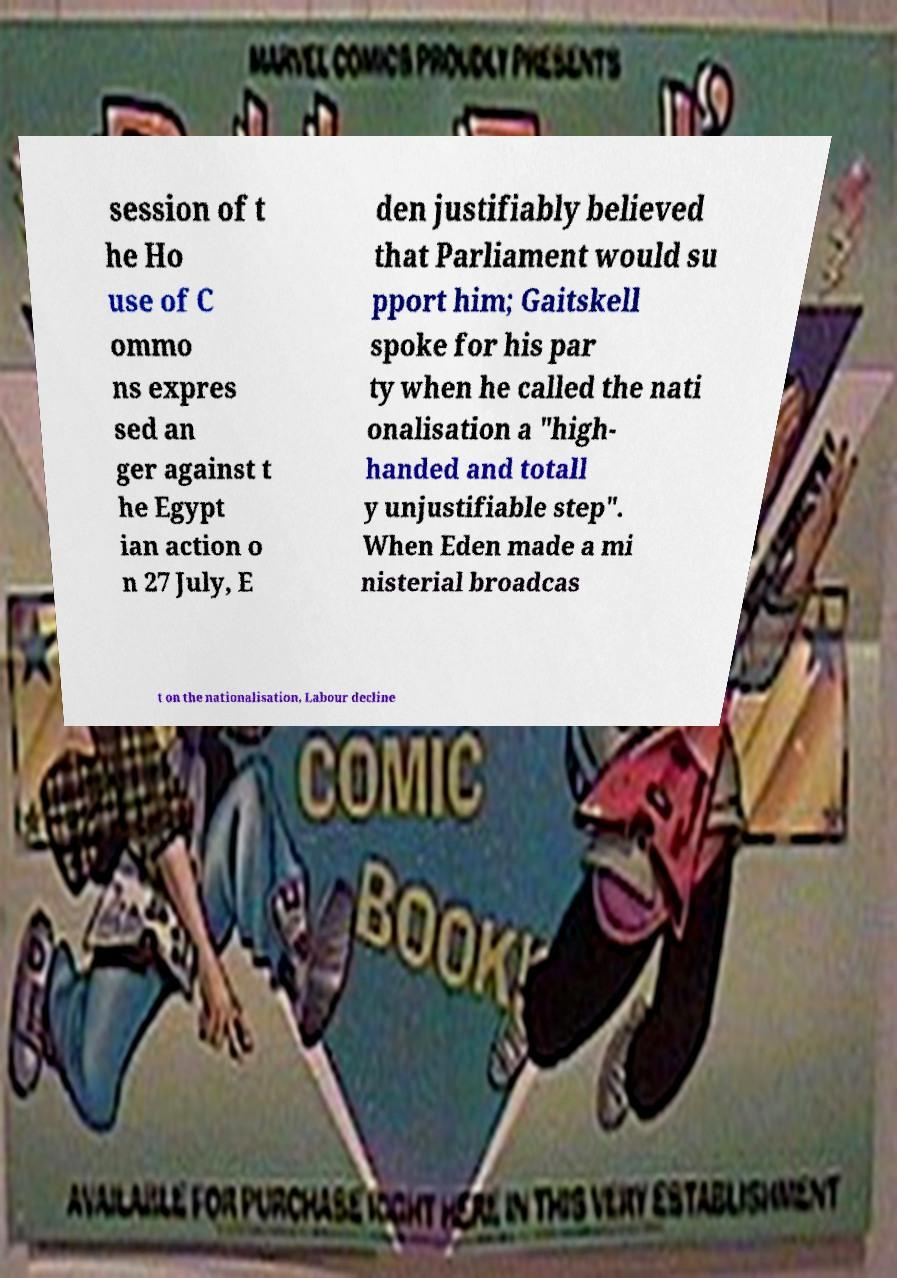There's text embedded in this image that I need extracted. Can you transcribe it verbatim? session of t he Ho use of C ommo ns expres sed an ger against t he Egypt ian action o n 27 July, E den justifiably believed that Parliament would su pport him; Gaitskell spoke for his par ty when he called the nati onalisation a "high- handed and totall y unjustifiable step". When Eden made a mi nisterial broadcas t on the nationalisation, Labour decline 